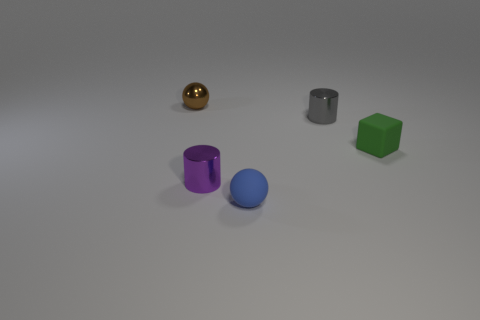The purple metallic thing that is the same size as the brown metallic sphere is what shape?
Keep it short and to the point. Cylinder. Do the ball in front of the green rubber thing and the tiny brown ball have the same size?
Your answer should be compact. Yes. There is a green cube that is the same size as the gray metal thing; what is its material?
Give a very brief answer. Rubber. There is a small cylinder that is in front of the tiny metal cylinder on the right side of the matte ball; is there a tiny thing behind it?
Your answer should be compact. Yes. Is there anything else that has the same shape as the small purple object?
Your answer should be compact. Yes. Is the color of the ball on the right side of the brown object the same as the small metal object that is right of the small purple shiny object?
Provide a succinct answer. No. Are there any large blue metallic things?
Offer a terse response. No. There is a matte object that is right of the shiny cylinder on the right side of the ball in front of the tiny brown metallic ball; what size is it?
Your response must be concise. Small. Do the tiny blue object and the rubber thing right of the gray metallic thing have the same shape?
Offer a terse response. No. Is there a shiny thing that has the same color as the rubber cube?
Offer a very short reply. No. 